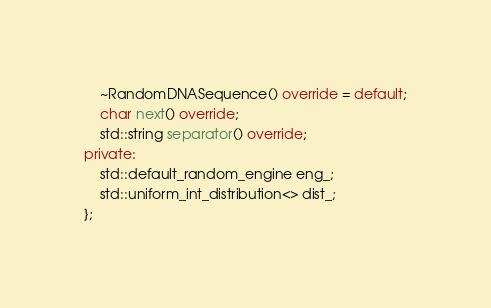Convert code to text. <code><loc_0><loc_0><loc_500><loc_500><_C++_>    ~RandomDNASequence() override = default;
    char next() override;
    std::string separator() override;
private:
    std::default_random_engine eng_;
    std::uniform_int_distribution<> dist_;
};
</code> 